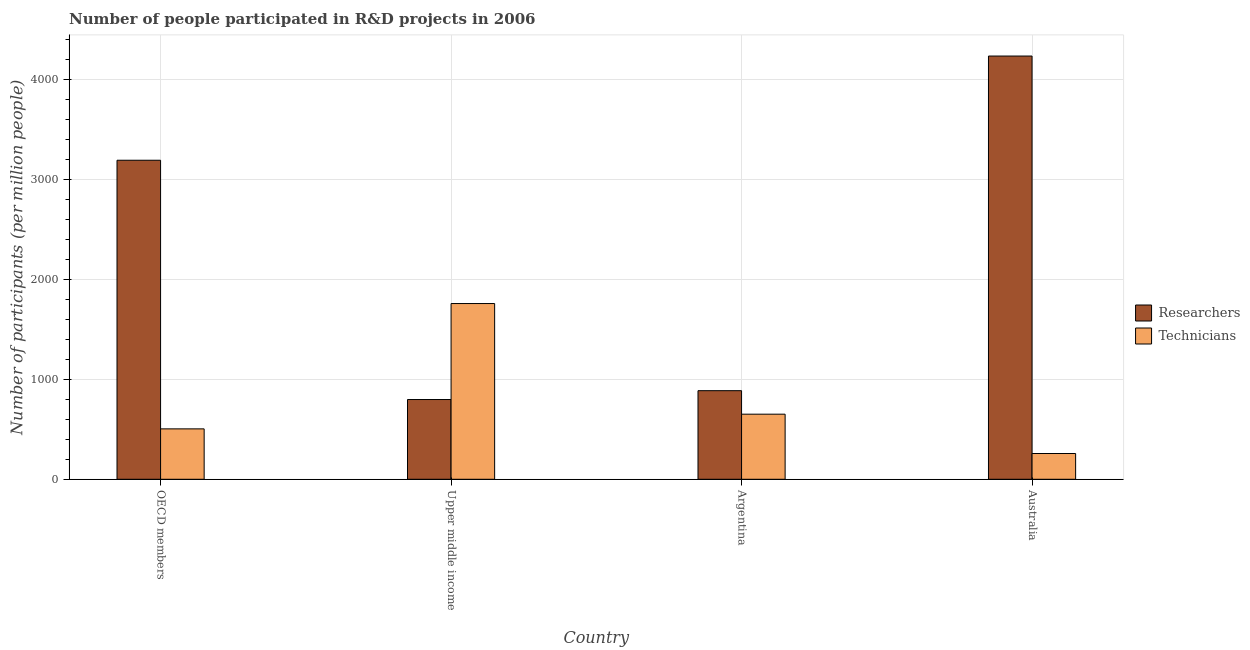Are the number of bars per tick equal to the number of legend labels?
Your answer should be very brief. Yes. How many bars are there on the 3rd tick from the left?
Provide a succinct answer. 2. What is the label of the 2nd group of bars from the left?
Offer a very short reply. Upper middle income. In how many cases, is the number of bars for a given country not equal to the number of legend labels?
Offer a terse response. 0. What is the number of technicians in OECD members?
Keep it short and to the point. 504.03. Across all countries, what is the maximum number of technicians?
Provide a succinct answer. 1757.05. Across all countries, what is the minimum number of researchers?
Your response must be concise. 797.38. In which country was the number of technicians maximum?
Keep it short and to the point. Upper middle income. What is the total number of researchers in the graph?
Make the answer very short. 9104.82. What is the difference between the number of technicians in OECD members and that in Upper middle income?
Your answer should be very brief. -1253.03. What is the difference between the number of technicians in Argentina and the number of researchers in OECD members?
Provide a succinct answer. -2539.09. What is the average number of researchers per country?
Ensure brevity in your answer.  2276.2. What is the difference between the number of technicians and number of researchers in Argentina?
Provide a short and direct response. -234.98. What is the ratio of the number of technicians in Argentina to that in Upper middle income?
Provide a short and direct response. 0.37. Is the number of researchers in Argentina less than that in Australia?
Ensure brevity in your answer.  Yes. Is the difference between the number of technicians in Australia and OECD members greater than the difference between the number of researchers in Australia and OECD members?
Offer a terse response. No. What is the difference between the highest and the second highest number of technicians?
Your answer should be very brief. 1106.26. What is the difference between the highest and the lowest number of technicians?
Offer a terse response. 1499.49. Is the sum of the number of technicians in Argentina and Upper middle income greater than the maximum number of researchers across all countries?
Provide a short and direct response. No. What does the 2nd bar from the left in Argentina represents?
Offer a terse response. Technicians. What does the 2nd bar from the right in Argentina represents?
Ensure brevity in your answer.  Researchers. How many bars are there?
Give a very brief answer. 8. Are all the bars in the graph horizontal?
Your answer should be compact. No. How many countries are there in the graph?
Make the answer very short. 4. What is the difference between two consecutive major ticks on the Y-axis?
Provide a short and direct response. 1000. Are the values on the major ticks of Y-axis written in scientific E-notation?
Keep it short and to the point. No. Does the graph contain grids?
Offer a very short reply. Yes. Where does the legend appear in the graph?
Keep it short and to the point. Center right. How many legend labels are there?
Provide a short and direct response. 2. How are the legend labels stacked?
Offer a very short reply. Vertical. What is the title of the graph?
Ensure brevity in your answer.  Number of people participated in R&D projects in 2006. Does "Under-5(female)" appear as one of the legend labels in the graph?
Provide a short and direct response. No. What is the label or title of the X-axis?
Offer a terse response. Country. What is the label or title of the Y-axis?
Make the answer very short. Number of participants (per million people). What is the Number of participants (per million people) of Researchers in OECD members?
Offer a very short reply. 3189.88. What is the Number of participants (per million people) of Technicians in OECD members?
Keep it short and to the point. 504.03. What is the Number of participants (per million people) of Researchers in Upper middle income?
Provide a succinct answer. 797.38. What is the Number of participants (per million people) of Technicians in Upper middle income?
Your answer should be compact. 1757.05. What is the Number of participants (per million people) of Researchers in Argentina?
Offer a very short reply. 885.77. What is the Number of participants (per million people) of Technicians in Argentina?
Keep it short and to the point. 650.79. What is the Number of participants (per million people) in Researchers in Australia?
Provide a succinct answer. 4231.78. What is the Number of participants (per million people) of Technicians in Australia?
Your response must be concise. 257.56. Across all countries, what is the maximum Number of participants (per million people) in Researchers?
Provide a succinct answer. 4231.78. Across all countries, what is the maximum Number of participants (per million people) of Technicians?
Your response must be concise. 1757.05. Across all countries, what is the minimum Number of participants (per million people) in Researchers?
Provide a short and direct response. 797.38. Across all countries, what is the minimum Number of participants (per million people) in Technicians?
Your response must be concise. 257.56. What is the total Number of participants (per million people) in Researchers in the graph?
Offer a terse response. 9104.82. What is the total Number of participants (per million people) in Technicians in the graph?
Give a very brief answer. 3169.43. What is the difference between the Number of participants (per million people) of Researchers in OECD members and that in Upper middle income?
Offer a very short reply. 2392.5. What is the difference between the Number of participants (per million people) of Technicians in OECD members and that in Upper middle income?
Your response must be concise. -1253.03. What is the difference between the Number of participants (per million people) in Researchers in OECD members and that in Argentina?
Ensure brevity in your answer.  2304.11. What is the difference between the Number of participants (per million people) of Technicians in OECD members and that in Argentina?
Offer a terse response. -146.77. What is the difference between the Number of participants (per million people) in Researchers in OECD members and that in Australia?
Make the answer very short. -1041.9. What is the difference between the Number of participants (per million people) in Technicians in OECD members and that in Australia?
Offer a very short reply. 246.46. What is the difference between the Number of participants (per million people) of Researchers in Upper middle income and that in Argentina?
Your answer should be compact. -88.39. What is the difference between the Number of participants (per million people) of Technicians in Upper middle income and that in Argentina?
Make the answer very short. 1106.26. What is the difference between the Number of participants (per million people) of Researchers in Upper middle income and that in Australia?
Make the answer very short. -3434.4. What is the difference between the Number of participants (per million people) in Technicians in Upper middle income and that in Australia?
Provide a succinct answer. 1499.49. What is the difference between the Number of participants (per million people) in Researchers in Argentina and that in Australia?
Your answer should be compact. -3346.01. What is the difference between the Number of participants (per million people) in Technicians in Argentina and that in Australia?
Your response must be concise. 393.23. What is the difference between the Number of participants (per million people) of Researchers in OECD members and the Number of participants (per million people) of Technicians in Upper middle income?
Provide a succinct answer. 1432.83. What is the difference between the Number of participants (per million people) of Researchers in OECD members and the Number of participants (per million people) of Technicians in Argentina?
Make the answer very short. 2539.09. What is the difference between the Number of participants (per million people) in Researchers in OECD members and the Number of participants (per million people) in Technicians in Australia?
Ensure brevity in your answer.  2932.32. What is the difference between the Number of participants (per million people) in Researchers in Upper middle income and the Number of participants (per million people) in Technicians in Argentina?
Your answer should be compact. 146.59. What is the difference between the Number of participants (per million people) of Researchers in Upper middle income and the Number of participants (per million people) of Technicians in Australia?
Your answer should be compact. 539.82. What is the difference between the Number of participants (per million people) of Researchers in Argentina and the Number of participants (per million people) of Technicians in Australia?
Ensure brevity in your answer.  628.21. What is the average Number of participants (per million people) in Researchers per country?
Keep it short and to the point. 2276.2. What is the average Number of participants (per million people) of Technicians per country?
Make the answer very short. 792.36. What is the difference between the Number of participants (per million people) of Researchers and Number of participants (per million people) of Technicians in OECD members?
Ensure brevity in your answer.  2685.86. What is the difference between the Number of participants (per million people) in Researchers and Number of participants (per million people) in Technicians in Upper middle income?
Provide a short and direct response. -959.67. What is the difference between the Number of participants (per million people) of Researchers and Number of participants (per million people) of Technicians in Argentina?
Provide a short and direct response. 234.98. What is the difference between the Number of participants (per million people) in Researchers and Number of participants (per million people) in Technicians in Australia?
Give a very brief answer. 3974.22. What is the ratio of the Number of participants (per million people) of Researchers in OECD members to that in Upper middle income?
Your response must be concise. 4. What is the ratio of the Number of participants (per million people) in Technicians in OECD members to that in Upper middle income?
Your answer should be very brief. 0.29. What is the ratio of the Number of participants (per million people) of Researchers in OECD members to that in Argentina?
Ensure brevity in your answer.  3.6. What is the ratio of the Number of participants (per million people) in Technicians in OECD members to that in Argentina?
Offer a very short reply. 0.77. What is the ratio of the Number of participants (per million people) of Researchers in OECD members to that in Australia?
Provide a short and direct response. 0.75. What is the ratio of the Number of participants (per million people) of Technicians in OECD members to that in Australia?
Offer a very short reply. 1.96. What is the ratio of the Number of participants (per million people) in Researchers in Upper middle income to that in Argentina?
Your response must be concise. 0.9. What is the ratio of the Number of participants (per million people) of Technicians in Upper middle income to that in Argentina?
Offer a terse response. 2.7. What is the ratio of the Number of participants (per million people) of Researchers in Upper middle income to that in Australia?
Keep it short and to the point. 0.19. What is the ratio of the Number of participants (per million people) of Technicians in Upper middle income to that in Australia?
Offer a very short reply. 6.82. What is the ratio of the Number of participants (per million people) in Researchers in Argentina to that in Australia?
Make the answer very short. 0.21. What is the ratio of the Number of participants (per million people) in Technicians in Argentina to that in Australia?
Give a very brief answer. 2.53. What is the difference between the highest and the second highest Number of participants (per million people) in Researchers?
Keep it short and to the point. 1041.9. What is the difference between the highest and the second highest Number of participants (per million people) in Technicians?
Give a very brief answer. 1106.26. What is the difference between the highest and the lowest Number of participants (per million people) in Researchers?
Provide a short and direct response. 3434.4. What is the difference between the highest and the lowest Number of participants (per million people) in Technicians?
Give a very brief answer. 1499.49. 